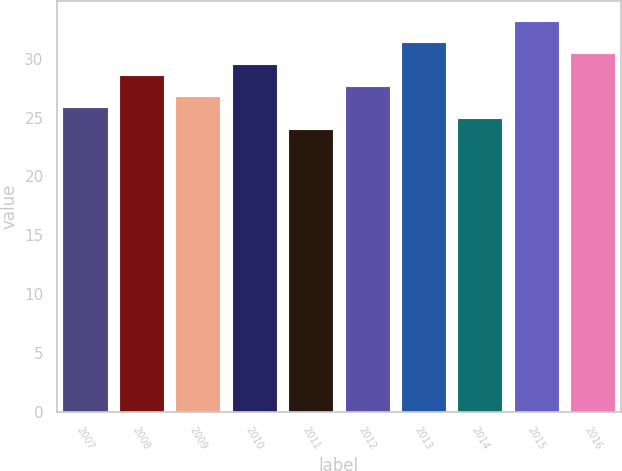<chart> <loc_0><loc_0><loc_500><loc_500><bar_chart><fcel>2007<fcel>2008<fcel>2009<fcel>2010<fcel>2011<fcel>2012<fcel>2013<fcel>2014<fcel>2015<fcel>2016<nl><fcel>25.89<fcel>28.65<fcel>26.81<fcel>29.57<fcel>24.05<fcel>27.73<fcel>31.41<fcel>24.97<fcel>33.23<fcel>30.49<nl></chart> 